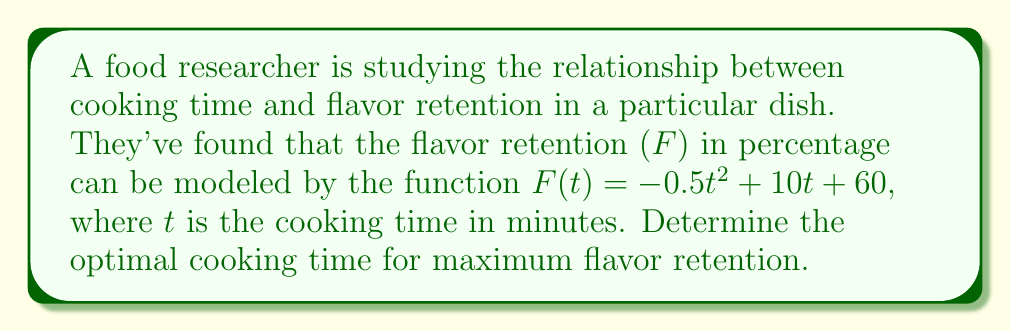Show me your answer to this math problem. To find the optimal cooking time for maximum flavor retention, we need to find the maximum point of the function $F(t) = -0.5t^2 + 10t + 60$. This can be done by following these steps:

1. Find the derivative of $F(t)$:
   $F'(t) = -t + 10$

2. Set the derivative equal to zero to find the critical point:
   $F'(t) = 0$
   $-t + 10 = 0$
   $t = 10$

3. Verify that this critical point is a maximum:
   Check the second derivative: $F''(t) = -1$
   Since $F''(t)$ is negative, the critical point is a maximum.

4. Therefore, the optimal cooking time for maximum flavor retention is 10 minutes.

To find the maximum flavor retention percentage:
$F(10) = -0.5(10)^2 + 10(10) + 60$
$= -50 + 100 + 60$
$= 110$

So, the maximum flavor retention is 110%.
Answer: 10 minutes 